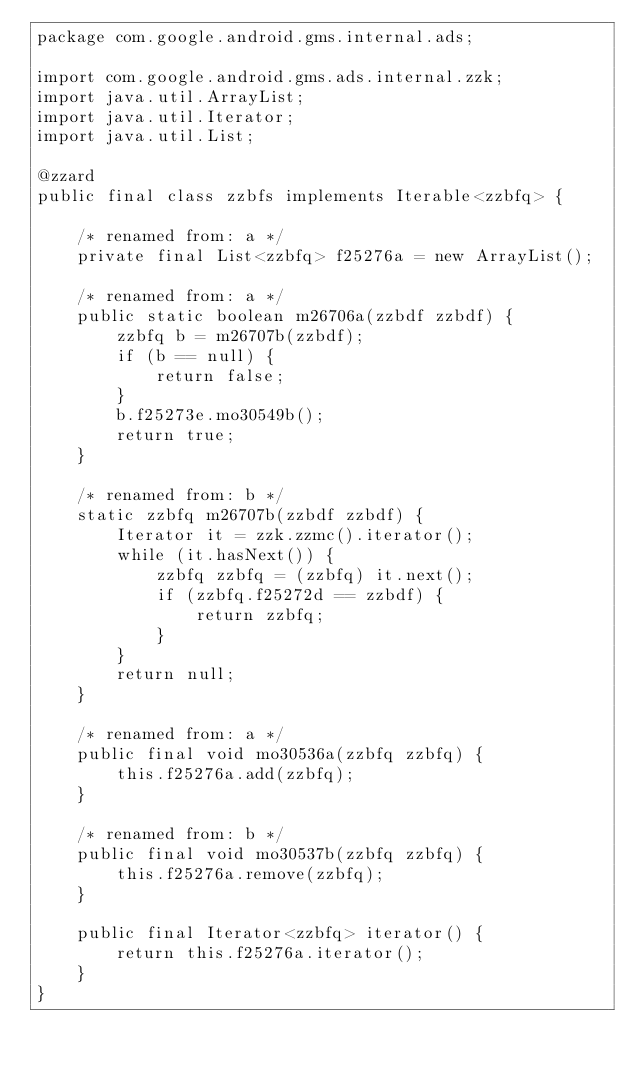Convert code to text. <code><loc_0><loc_0><loc_500><loc_500><_Java_>package com.google.android.gms.internal.ads;

import com.google.android.gms.ads.internal.zzk;
import java.util.ArrayList;
import java.util.Iterator;
import java.util.List;

@zzard
public final class zzbfs implements Iterable<zzbfq> {

    /* renamed from: a */
    private final List<zzbfq> f25276a = new ArrayList();

    /* renamed from: a */
    public static boolean m26706a(zzbdf zzbdf) {
        zzbfq b = m26707b(zzbdf);
        if (b == null) {
            return false;
        }
        b.f25273e.mo30549b();
        return true;
    }

    /* renamed from: b */
    static zzbfq m26707b(zzbdf zzbdf) {
        Iterator it = zzk.zzmc().iterator();
        while (it.hasNext()) {
            zzbfq zzbfq = (zzbfq) it.next();
            if (zzbfq.f25272d == zzbdf) {
                return zzbfq;
            }
        }
        return null;
    }

    /* renamed from: a */
    public final void mo30536a(zzbfq zzbfq) {
        this.f25276a.add(zzbfq);
    }

    /* renamed from: b */
    public final void mo30537b(zzbfq zzbfq) {
        this.f25276a.remove(zzbfq);
    }

    public final Iterator<zzbfq> iterator() {
        return this.f25276a.iterator();
    }
}
</code> 